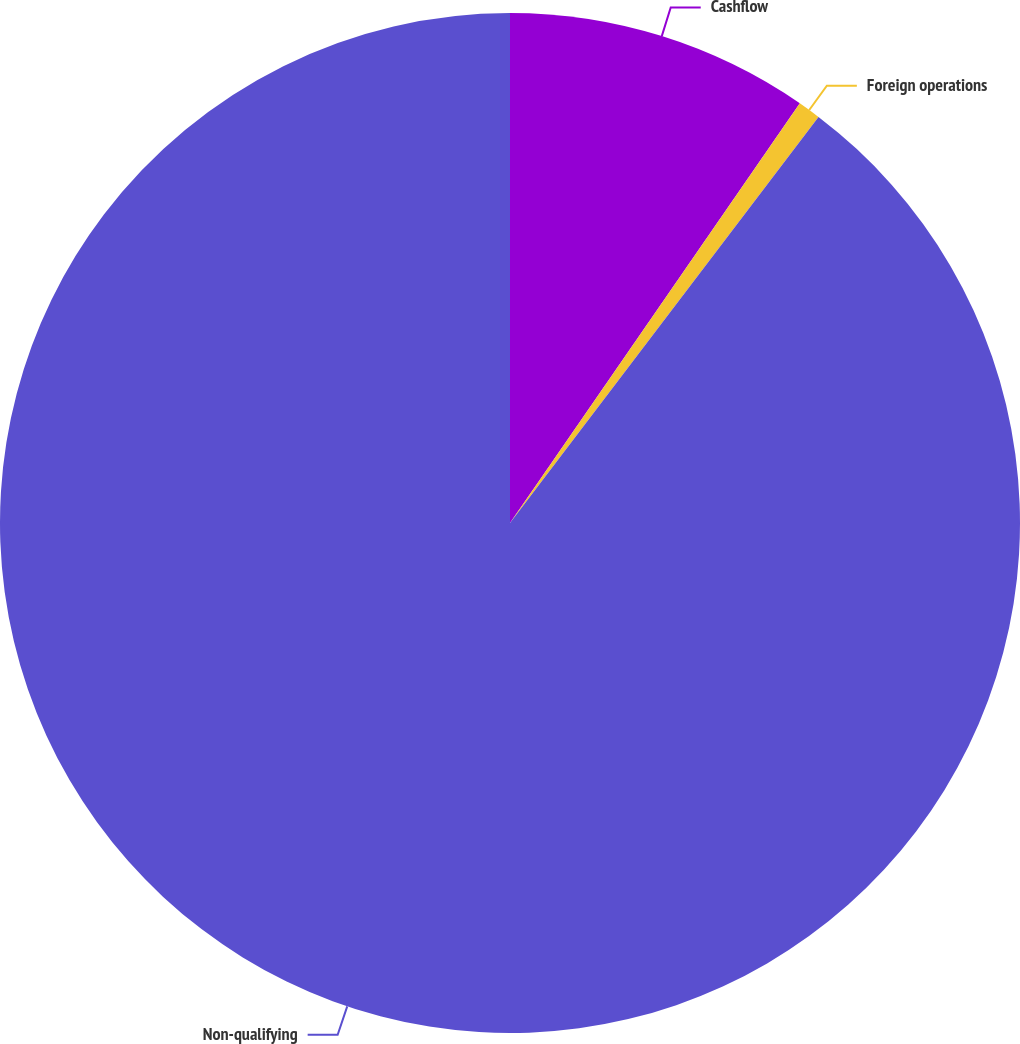<chart> <loc_0><loc_0><loc_500><loc_500><pie_chart><fcel>Cashflow<fcel>Foreign operations<fcel>Non-qualifying<nl><fcel>9.62%<fcel>0.72%<fcel>89.66%<nl></chart> 